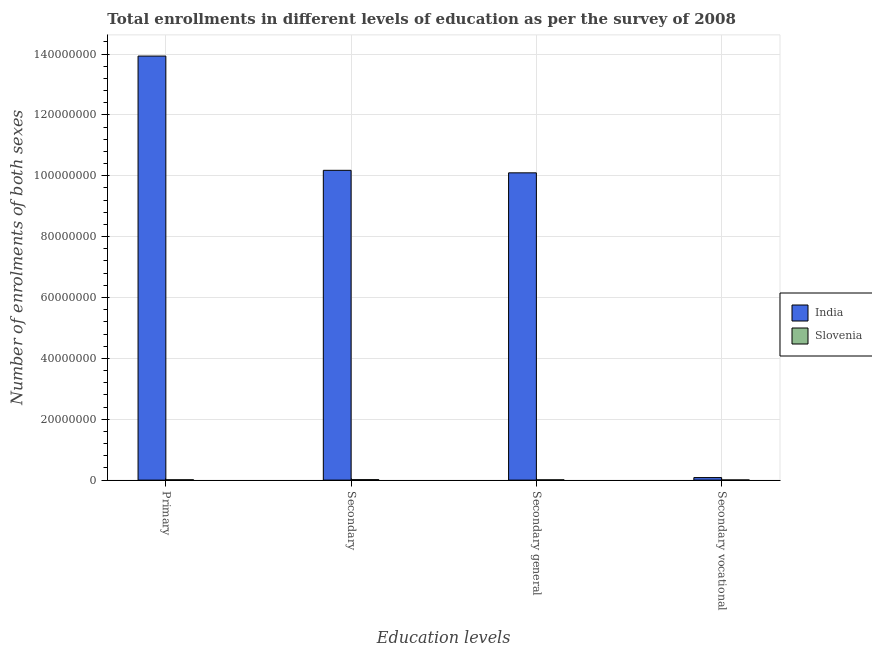How many different coloured bars are there?
Your answer should be very brief. 2. How many groups of bars are there?
Keep it short and to the point. 4. How many bars are there on the 3rd tick from the left?
Offer a terse response. 2. What is the label of the 4th group of bars from the left?
Provide a succinct answer. Secondary vocational. What is the number of enrolments in secondary general education in Slovenia?
Your answer should be very brief. 9.39e+04. Across all countries, what is the maximum number of enrolments in secondary vocational education?
Your answer should be very brief. 8.29e+05. Across all countries, what is the minimum number of enrolments in secondary vocational education?
Offer a terse response. 5.36e+04. In which country was the number of enrolments in primary education maximum?
Your answer should be very brief. India. In which country was the number of enrolments in secondary education minimum?
Your response must be concise. Slovenia. What is the total number of enrolments in primary education in the graph?
Provide a short and direct response. 1.39e+08. What is the difference between the number of enrolments in primary education in India and that in Slovenia?
Make the answer very short. 1.39e+08. What is the difference between the number of enrolments in primary education in Slovenia and the number of enrolments in secondary education in India?
Your response must be concise. -1.02e+08. What is the average number of enrolments in secondary general education per country?
Offer a terse response. 5.05e+07. What is the difference between the number of enrolments in primary education and number of enrolments in secondary vocational education in Slovenia?
Your answer should be compact. 5.37e+04. What is the ratio of the number of enrolments in secondary vocational education in India to that in Slovenia?
Offer a very short reply. 15.48. What is the difference between the highest and the second highest number of enrolments in primary education?
Ensure brevity in your answer.  1.39e+08. What is the difference between the highest and the lowest number of enrolments in primary education?
Give a very brief answer. 1.39e+08. Is the sum of the number of enrolments in primary education in India and Slovenia greater than the maximum number of enrolments in secondary general education across all countries?
Your answer should be compact. Yes. Is it the case that in every country, the sum of the number of enrolments in secondary education and number of enrolments in secondary vocational education is greater than the sum of number of enrolments in secondary general education and number of enrolments in primary education?
Provide a succinct answer. No. Are all the bars in the graph horizontal?
Provide a succinct answer. No. Does the graph contain grids?
Offer a very short reply. Yes. Where does the legend appear in the graph?
Your response must be concise. Center right. How are the legend labels stacked?
Provide a succinct answer. Vertical. What is the title of the graph?
Your response must be concise. Total enrollments in different levels of education as per the survey of 2008. What is the label or title of the X-axis?
Make the answer very short. Education levels. What is the label or title of the Y-axis?
Give a very brief answer. Number of enrolments of both sexes. What is the Number of enrolments of both sexes in India in Primary?
Offer a very short reply. 1.39e+08. What is the Number of enrolments of both sexes of Slovenia in Primary?
Give a very brief answer. 1.07e+05. What is the Number of enrolments of both sexes in India in Secondary?
Your answer should be very brief. 1.02e+08. What is the Number of enrolments of both sexes of Slovenia in Secondary?
Offer a terse response. 1.47e+05. What is the Number of enrolments of both sexes of India in Secondary general?
Your response must be concise. 1.01e+08. What is the Number of enrolments of both sexes of Slovenia in Secondary general?
Offer a terse response. 9.39e+04. What is the Number of enrolments of both sexes of India in Secondary vocational?
Your answer should be compact. 8.29e+05. What is the Number of enrolments of both sexes in Slovenia in Secondary vocational?
Ensure brevity in your answer.  5.36e+04. Across all Education levels, what is the maximum Number of enrolments of both sexes in India?
Offer a very short reply. 1.39e+08. Across all Education levels, what is the maximum Number of enrolments of both sexes in Slovenia?
Keep it short and to the point. 1.47e+05. Across all Education levels, what is the minimum Number of enrolments of both sexes of India?
Your response must be concise. 8.29e+05. Across all Education levels, what is the minimum Number of enrolments of both sexes of Slovenia?
Your response must be concise. 5.36e+04. What is the total Number of enrolments of both sexes of India in the graph?
Provide a succinct answer. 3.43e+08. What is the total Number of enrolments of both sexes in Slovenia in the graph?
Provide a succinct answer. 4.02e+05. What is the difference between the Number of enrolments of both sexes in India in Primary and that in Secondary?
Make the answer very short. 3.75e+07. What is the difference between the Number of enrolments of both sexes in Slovenia in Primary and that in Secondary?
Your answer should be very brief. -4.02e+04. What is the difference between the Number of enrolments of both sexes in India in Primary and that in Secondary general?
Keep it short and to the point. 3.84e+07. What is the difference between the Number of enrolments of both sexes of Slovenia in Primary and that in Secondary general?
Ensure brevity in your answer.  1.34e+04. What is the difference between the Number of enrolments of both sexes of India in Primary and that in Secondary vocational?
Keep it short and to the point. 1.38e+08. What is the difference between the Number of enrolments of both sexes of Slovenia in Primary and that in Secondary vocational?
Offer a terse response. 5.37e+04. What is the difference between the Number of enrolments of both sexes of India in Secondary and that in Secondary general?
Offer a terse response. 8.29e+05. What is the difference between the Number of enrolments of both sexes in Slovenia in Secondary and that in Secondary general?
Provide a succinct answer. 5.36e+04. What is the difference between the Number of enrolments of both sexes in India in Secondary and that in Secondary vocational?
Your response must be concise. 1.01e+08. What is the difference between the Number of enrolments of both sexes of Slovenia in Secondary and that in Secondary vocational?
Provide a succinct answer. 9.39e+04. What is the difference between the Number of enrolments of both sexes of India in Secondary general and that in Secondary vocational?
Keep it short and to the point. 1.00e+08. What is the difference between the Number of enrolments of both sexes of Slovenia in Secondary general and that in Secondary vocational?
Keep it short and to the point. 4.03e+04. What is the difference between the Number of enrolments of both sexes in India in Primary and the Number of enrolments of both sexes in Slovenia in Secondary?
Your response must be concise. 1.39e+08. What is the difference between the Number of enrolments of both sexes in India in Primary and the Number of enrolments of both sexes in Slovenia in Secondary general?
Provide a short and direct response. 1.39e+08. What is the difference between the Number of enrolments of both sexes of India in Primary and the Number of enrolments of both sexes of Slovenia in Secondary vocational?
Your answer should be compact. 1.39e+08. What is the difference between the Number of enrolments of both sexes in India in Secondary and the Number of enrolments of both sexes in Slovenia in Secondary general?
Your response must be concise. 1.02e+08. What is the difference between the Number of enrolments of both sexes of India in Secondary and the Number of enrolments of both sexes of Slovenia in Secondary vocational?
Ensure brevity in your answer.  1.02e+08. What is the difference between the Number of enrolments of both sexes in India in Secondary general and the Number of enrolments of both sexes in Slovenia in Secondary vocational?
Give a very brief answer. 1.01e+08. What is the average Number of enrolments of both sexes in India per Education levels?
Provide a succinct answer. 8.57e+07. What is the average Number of enrolments of both sexes of Slovenia per Education levels?
Give a very brief answer. 1.01e+05. What is the difference between the Number of enrolments of both sexes of India and Number of enrolments of both sexes of Slovenia in Primary?
Your answer should be very brief. 1.39e+08. What is the difference between the Number of enrolments of both sexes in India and Number of enrolments of both sexes in Slovenia in Secondary?
Provide a short and direct response. 1.02e+08. What is the difference between the Number of enrolments of both sexes of India and Number of enrolments of both sexes of Slovenia in Secondary general?
Your response must be concise. 1.01e+08. What is the difference between the Number of enrolments of both sexes of India and Number of enrolments of both sexes of Slovenia in Secondary vocational?
Make the answer very short. 7.76e+05. What is the ratio of the Number of enrolments of both sexes in India in Primary to that in Secondary?
Give a very brief answer. 1.37. What is the ratio of the Number of enrolments of both sexes in Slovenia in Primary to that in Secondary?
Your answer should be very brief. 0.73. What is the ratio of the Number of enrolments of both sexes of India in Primary to that in Secondary general?
Give a very brief answer. 1.38. What is the ratio of the Number of enrolments of both sexes in Slovenia in Primary to that in Secondary general?
Ensure brevity in your answer.  1.14. What is the ratio of the Number of enrolments of both sexes of India in Primary to that in Secondary vocational?
Keep it short and to the point. 167.98. What is the ratio of the Number of enrolments of both sexes of Slovenia in Primary to that in Secondary vocational?
Make the answer very short. 2. What is the ratio of the Number of enrolments of both sexes of India in Secondary to that in Secondary general?
Your response must be concise. 1.01. What is the ratio of the Number of enrolments of both sexes in Slovenia in Secondary to that in Secondary general?
Make the answer very short. 1.57. What is the ratio of the Number of enrolments of both sexes of India in Secondary to that in Secondary vocational?
Give a very brief answer. 122.72. What is the ratio of the Number of enrolments of both sexes in Slovenia in Secondary to that in Secondary vocational?
Offer a terse response. 2.75. What is the ratio of the Number of enrolments of both sexes of India in Secondary general to that in Secondary vocational?
Your answer should be very brief. 121.72. What is the ratio of the Number of enrolments of both sexes of Slovenia in Secondary general to that in Secondary vocational?
Keep it short and to the point. 1.75. What is the difference between the highest and the second highest Number of enrolments of both sexes of India?
Make the answer very short. 3.75e+07. What is the difference between the highest and the second highest Number of enrolments of both sexes in Slovenia?
Offer a terse response. 4.02e+04. What is the difference between the highest and the lowest Number of enrolments of both sexes in India?
Your answer should be very brief. 1.38e+08. What is the difference between the highest and the lowest Number of enrolments of both sexes of Slovenia?
Your response must be concise. 9.39e+04. 